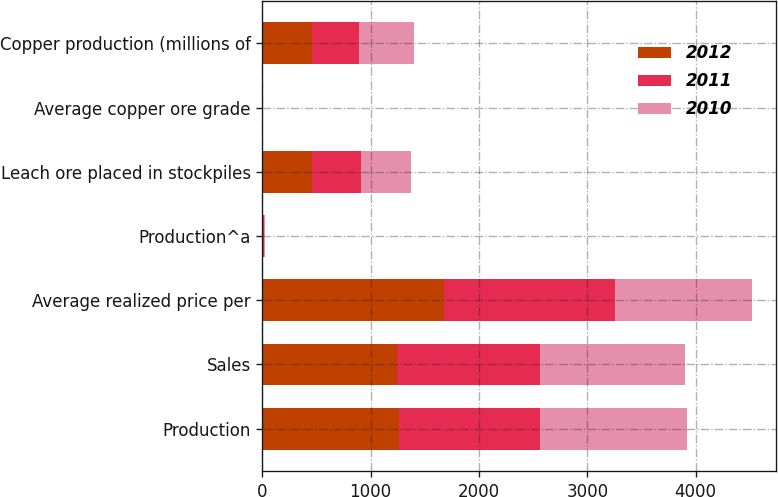Convert chart. <chart><loc_0><loc_0><loc_500><loc_500><stacked_bar_chart><ecel><fcel>Production<fcel>Sales<fcel>Average realized price per<fcel>Production^a<fcel>Leach ore placed in stockpiles<fcel>Average copper ore grade<fcel>Copper production (millions of<nl><fcel>2012<fcel>1257<fcel>1245<fcel>1673<fcel>8<fcel>457<fcel>0.55<fcel>457<nl><fcel>2011<fcel>1306<fcel>1322<fcel>1580<fcel>10<fcel>457<fcel>0.5<fcel>439<nl><fcel>2010<fcel>1354<fcel>1335<fcel>1263<fcel>7<fcel>457<fcel>0.41<fcel>504<nl></chart> 